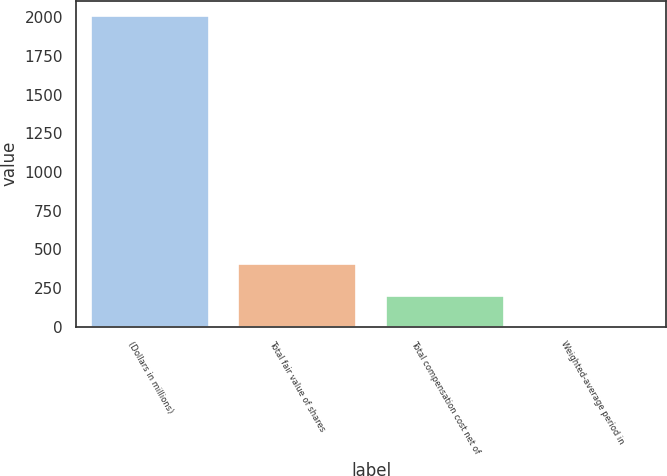Convert chart. <chart><loc_0><loc_0><loc_500><loc_500><bar_chart><fcel>(Dollars in millions)<fcel>Total fair value of shares<fcel>Total compensation cost net of<fcel>Weighted-average period in<nl><fcel>2009<fcel>402.6<fcel>201.8<fcel>1<nl></chart> 